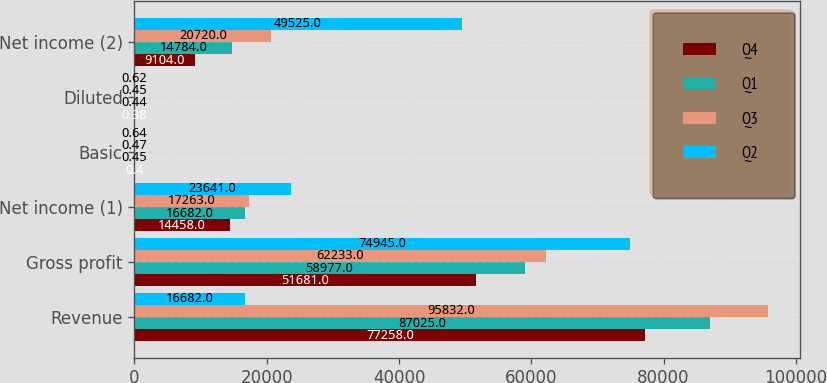Convert chart to OTSL. <chart><loc_0><loc_0><loc_500><loc_500><stacked_bar_chart><ecel><fcel>Revenue<fcel>Gross profit<fcel>Net income (1)<fcel>Basic<fcel>Diluted<fcel>Net income (2)<nl><fcel>Q4<fcel>77258<fcel>51681<fcel>14458<fcel>0.4<fcel>0.38<fcel>9104<nl><fcel>Q1<fcel>87025<fcel>58977<fcel>16682<fcel>0.45<fcel>0.44<fcel>14784<nl><fcel>Q3<fcel>95832<fcel>62233<fcel>17263<fcel>0.47<fcel>0.45<fcel>20720<nl><fcel>Q2<fcel>16682<fcel>74945<fcel>23641<fcel>0.64<fcel>0.62<fcel>49525<nl></chart> 